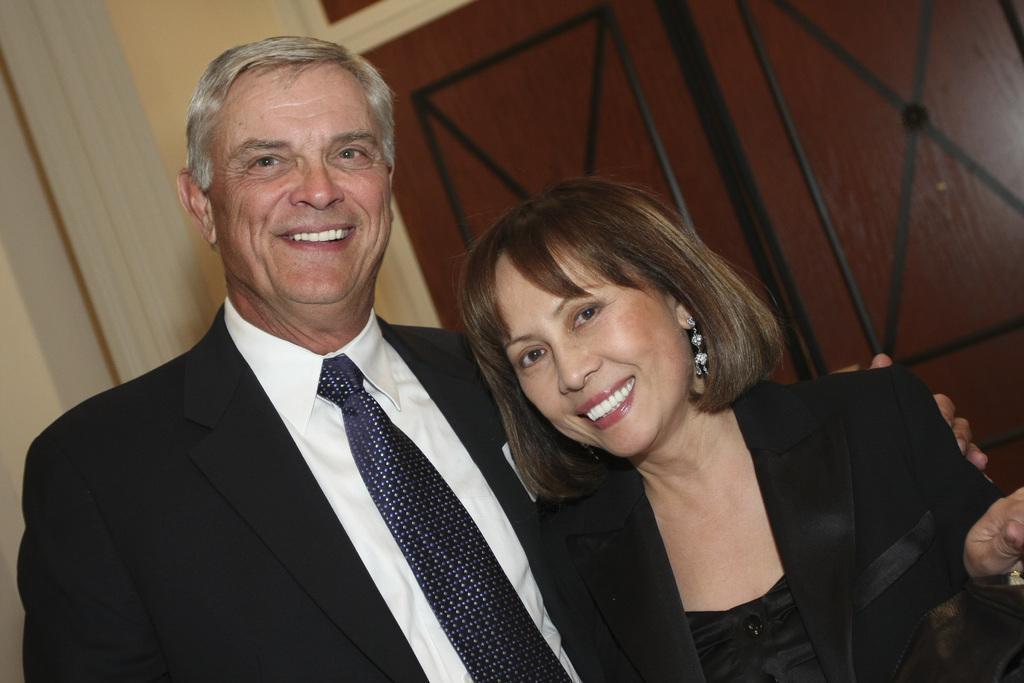Describe this image in one or two sentences. In this image, we can see a woman and man are standing side by side. They are watching and smiling. Here a man is holding a woman. Background there is a wall and door. 